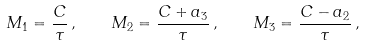Convert formula to latex. <formula><loc_0><loc_0><loc_500><loc_500>M _ { 1 } = \frac { C } { \tau } \, , \quad M _ { 2 } = \frac { C + a _ { 3 } } { \tau } \, , \quad M _ { 3 } = \frac { C - a _ { 2 } } { \tau } \, ,</formula> 